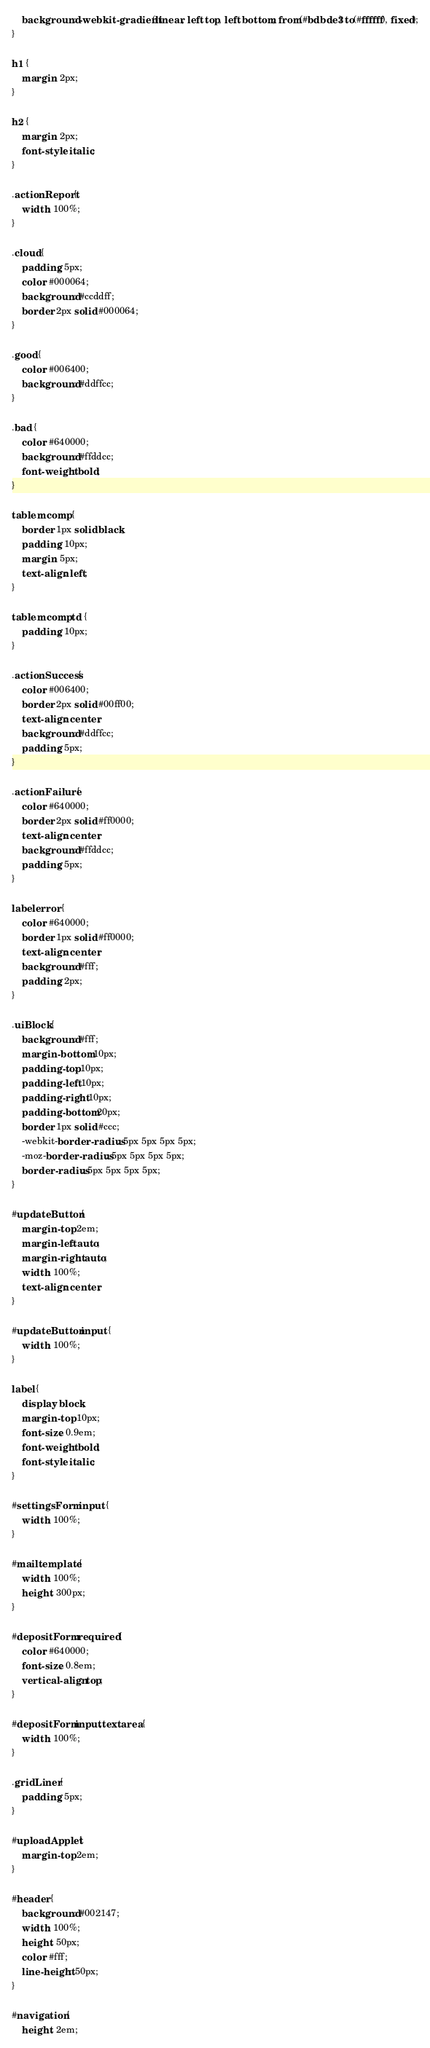Convert code to text. <code><loc_0><loc_0><loc_500><loc_500><_CSS_>	background: -webkit-gradient(linear, left top, left bottom, from(#bdbde3) to(#ffffff), fixed);
}

h1 {
	margin: 2px;
}

h2 {
	margin: 2px;
	font-style: italic;
}

.actionReport {
	width: 100%;
}

.cloud {
	padding: 5px;
	color: #000064;
	background: #ccddff;
	border: 2px solid #000064;
}

.good {
	color: #006400;
	background: #ddffcc;
}

.bad {
	color: #640000;
	background: #ffddcc;
	font-weight: bold;
}

table.mcomp {
	border: 1px solid black;
	padding: 10px;
	margin: 5px;
	text-align: left;
}

table.mcomp td {
	padding: 10px;
}

.actionSuccess {
	color: #006400;
	border: 2px solid #00ff00;
	text-align: center;
	background: #ddffcc;
	padding: 5px;
}

.actionFailure {
	color: #640000;
	border: 2px solid #ff0000;
	text-align: center;
	background: #ffddcc;
	padding: 5px;
}

label.error {
	color: #640000;
	border: 1px solid #ff0000;
	text-align: center;
	background: #fff;
	padding: 2px;
}

.uiBlock {
	background: #fff;
	margin-bottom: 10px;
	padding-top: 10px;
	padding-left: 10px;
	padding-right: 10px;
	padding-bottom: 20px;
	border: 1px solid #ccc;
	-webkit-border-radius: 5px 5px 5px 5px;
	-moz-border-radius: 5px 5px 5px 5px;
	border-radius: 5px 5px 5px 5px;
}

#updateButton {
	margin-top: 2em;
	margin-left: auto;
	margin-right: auto;
	width: 100%;
	text-align: center;
}

#updateButton input {
	width: 100%;
}

label {
	display: block;
	margin-top: 10px;
	font-size: 0.9em;
	font-weight: bold;
	font-style: italic;
}

#settingsForm input {
	width: 100%;
}

#mailtemplate {
	width: 100%;
	height: 300px;
}

#depositForm .required {
	color: #640000;
	font-size: 0.8em;
	vertical-align: top;
}

#depositForm input,textarea {
	width: 100%;
}

.gridLiner {
	padding: 5px;
}

#uploadApplet {
	margin-top: 2em;
}

#header {
	background: #002147;
	width: 100%;
	height: 50px;
	color: #fff;
	line-height: 50px;
}

#navigation {
	height: 2em;</code> 